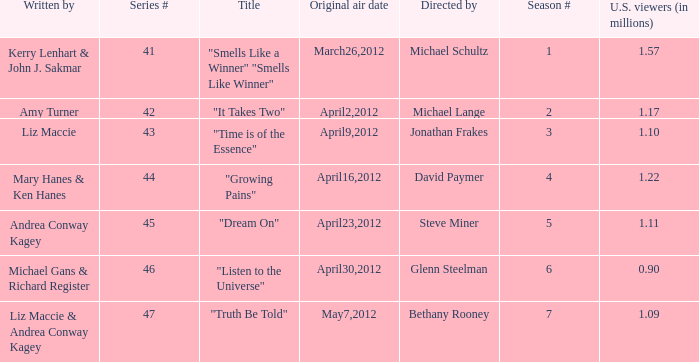What is the title of the episode/s written by Michael Gans & Richard Register? "Listen to the Universe". 